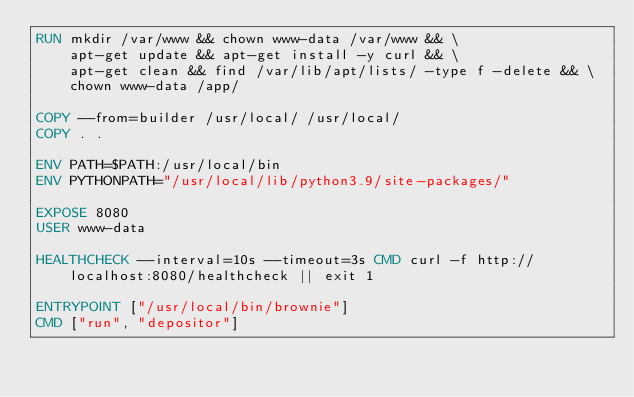Convert code to text. <code><loc_0><loc_0><loc_500><loc_500><_Dockerfile_>RUN mkdir /var/www && chown www-data /var/www && \
    apt-get update && apt-get install -y curl && \
    apt-get clean && find /var/lib/apt/lists/ -type f -delete && \
    chown www-data /app/

COPY --from=builder /usr/local/ /usr/local/
COPY . .

ENV PATH=$PATH:/usr/local/bin
ENV PYTHONPATH="/usr/local/lib/python3.9/site-packages/"

EXPOSE 8080
USER www-data

HEALTHCHECK --interval=10s --timeout=3s CMD curl -f http://localhost:8080/healthcheck || exit 1

ENTRYPOINT ["/usr/local/bin/brownie"]
CMD ["run", "depositor"]
</code> 